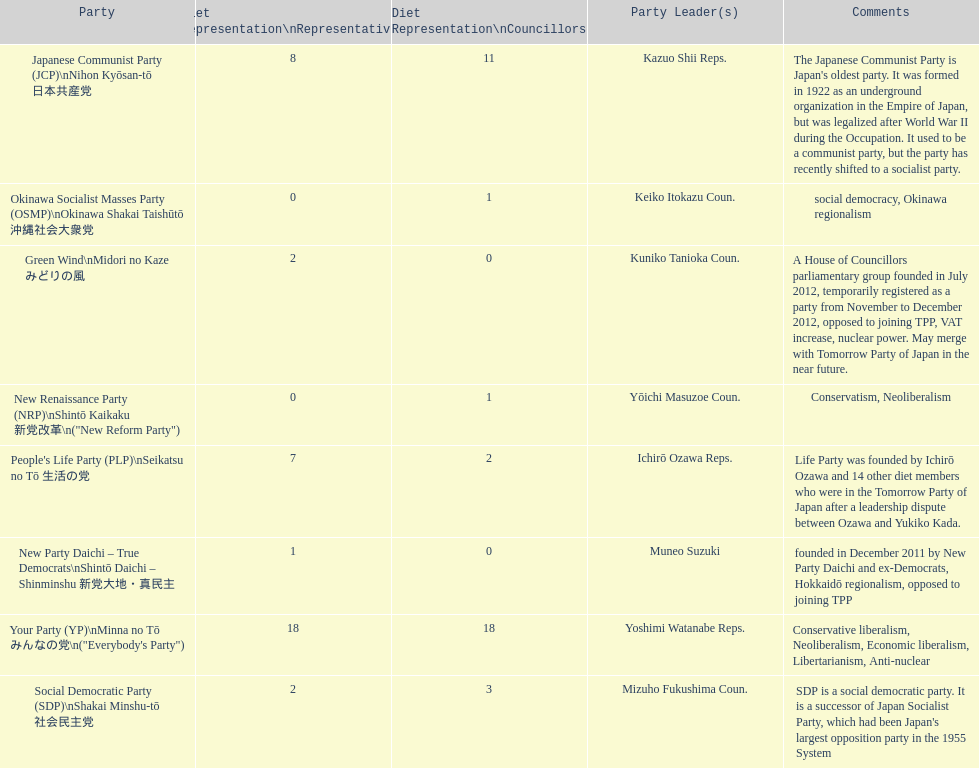People's life party has at most, how many party leaders? 1. Could you parse the entire table as a dict? {'header': ['Party', 'Diet Representation\\nRepresentatives', 'Diet Representation\\nCouncillors', 'Party Leader(s)', 'Comments'], 'rows': [['Japanese Communist Party (JCP)\\nNihon Kyōsan-tō 日本共産党', '8', '11', 'Kazuo Shii Reps.', "The Japanese Communist Party is Japan's oldest party. It was formed in 1922 as an underground organization in the Empire of Japan, but was legalized after World War II during the Occupation. It used to be a communist party, but the party has recently shifted to a socialist party."], ['Okinawa Socialist Masses Party (OSMP)\\nOkinawa Shakai Taishūtō 沖縄社会大衆党', '0', '1', 'Keiko Itokazu Coun.', 'social democracy, Okinawa regionalism'], ['Green Wind\\nMidori no Kaze みどりの風', '2', '0', 'Kuniko Tanioka Coun.', 'A House of Councillors parliamentary group founded in July 2012, temporarily registered as a party from November to December 2012, opposed to joining TPP, VAT increase, nuclear power. May merge with Tomorrow Party of Japan in the near future.'], ['New Renaissance Party (NRP)\\nShintō Kaikaku 新党改革\\n("New Reform Party")', '0', '1', 'Yōichi Masuzoe Coun.', 'Conservatism, Neoliberalism'], ["People's Life Party (PLP)\\nSeikatsu no Tō 生活の党", '7', '2', 'Ichirō Ozawa Reps.', 'Life Party was founded by Ichirō Ozawa and 14 other diet members who were in the Tomorrow Party of Japan after a leadership dispute between Ozawa and Yukiko Kada.'], ['New Party Daichi – True Democrats\\nShintō Daichi – Shinminshu 新党大地・真民主', '1', '0', 'Muneo Suzuki', 'founded in December 2011 by New Party Daichi and ex-Democrats, Hokkaidō regionalism, opposed to joining TPP'], ['Your Party (YP)\\nMinna no Tō みんなの党\\n("Everybody\'s Party")', '18', '18', 'Yoshimi Watanabe Reps.', 'Conservative liberalism, Neoliberalism, Economic liberalism, Libertarianism, Anti-nuclear'], ['Social Democratic Party (SDP)\\nShakai Minshu-tō 社会民主党', '2', '3', 'Mizuho Fukushima Coun.', "SDP is a social democratic party. It is a successor of Japan Socialist Party, which had been Japan's largest opposition party in the 1955 System"]]} 